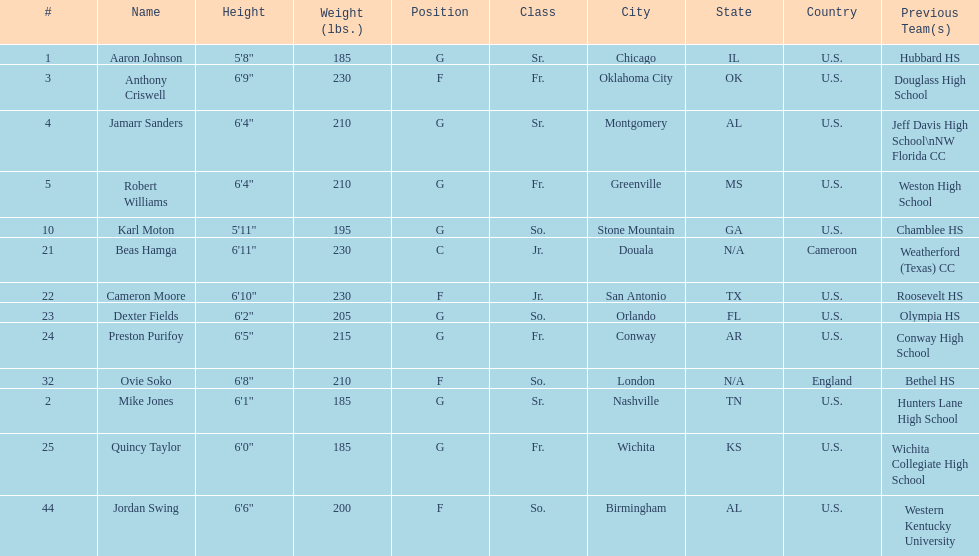What is the number of seniors on the team? 3. 